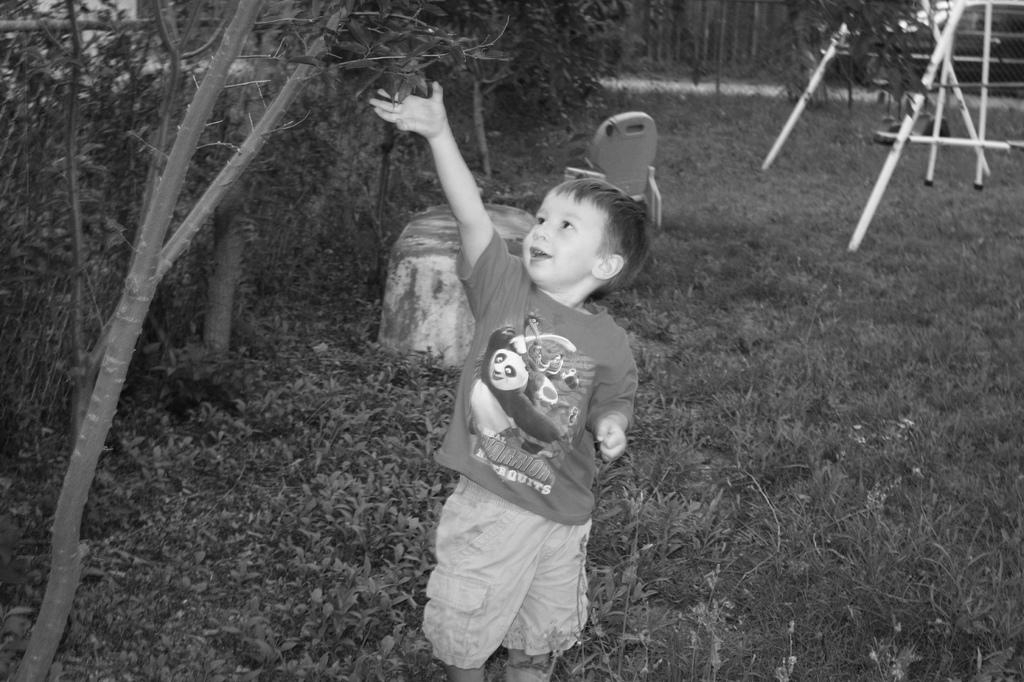What is the main subject of the image? The main subject of the image is a kid. Where is the kid standing? The kid is standing on a greenery ground. What is the kid doing in the image? The kid is touching leaves above him. What can be seen beside the kid? There is a fence beside the kid. What is visible behind the kid? There are some other objects behind the kid. How many tomatoes are hanging from the fence in the image? There are no tomatoes visible in the image; the focus is on the kid and the leaves. 